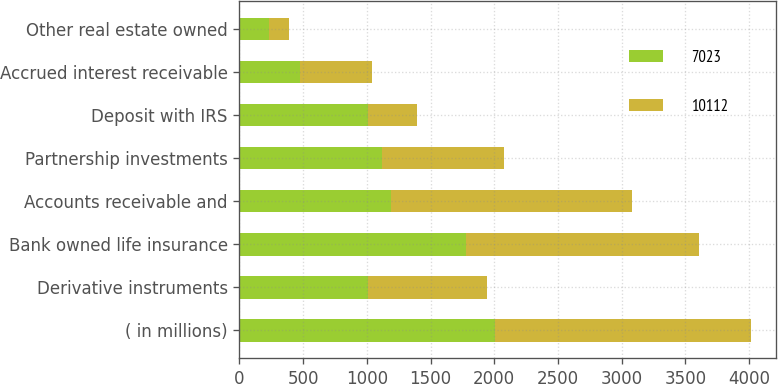Convert chart to OTSL. <chart><loc_0><loc_0><loc_500><loc_500><stacked_bar_chart><ecel><fcel>( in millions)<fcel>Derivative instruments<fcel>Bank owned life insurance<fcel>Accounts receivable and<fcel>Partnership investments<fcel>Deposit with IRS<fcel>Accrued interest receivable<fcel>Other real estate owned<nl><fcel>7023<fcel>2008<fcel>1007<fcel>1777<fcel>1188<fcel>1121<fcel>1007<fcel>478<fcel>231<nl><fcel>10112<fcel>2007<fcel>939<fcel>1832<fcel>1892<fcel>958<fcel>386<fcel>564<fcel>159<nl></chart> 